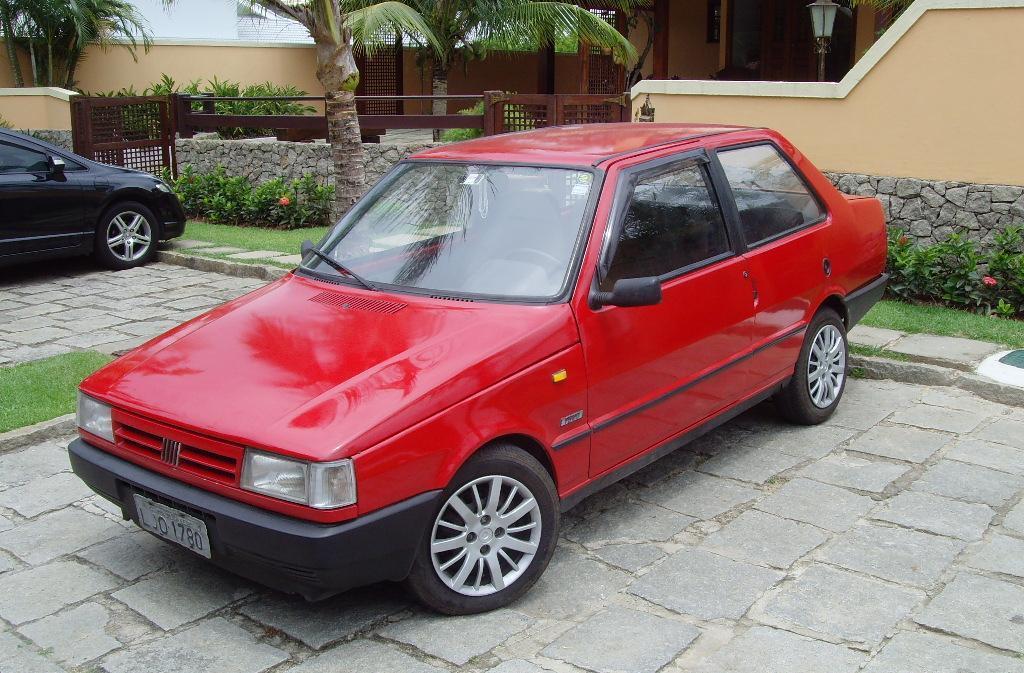Describe this image in one or two sentences. In the center of the image there are cars. In the background we can see a building and trees. There is a fence. 